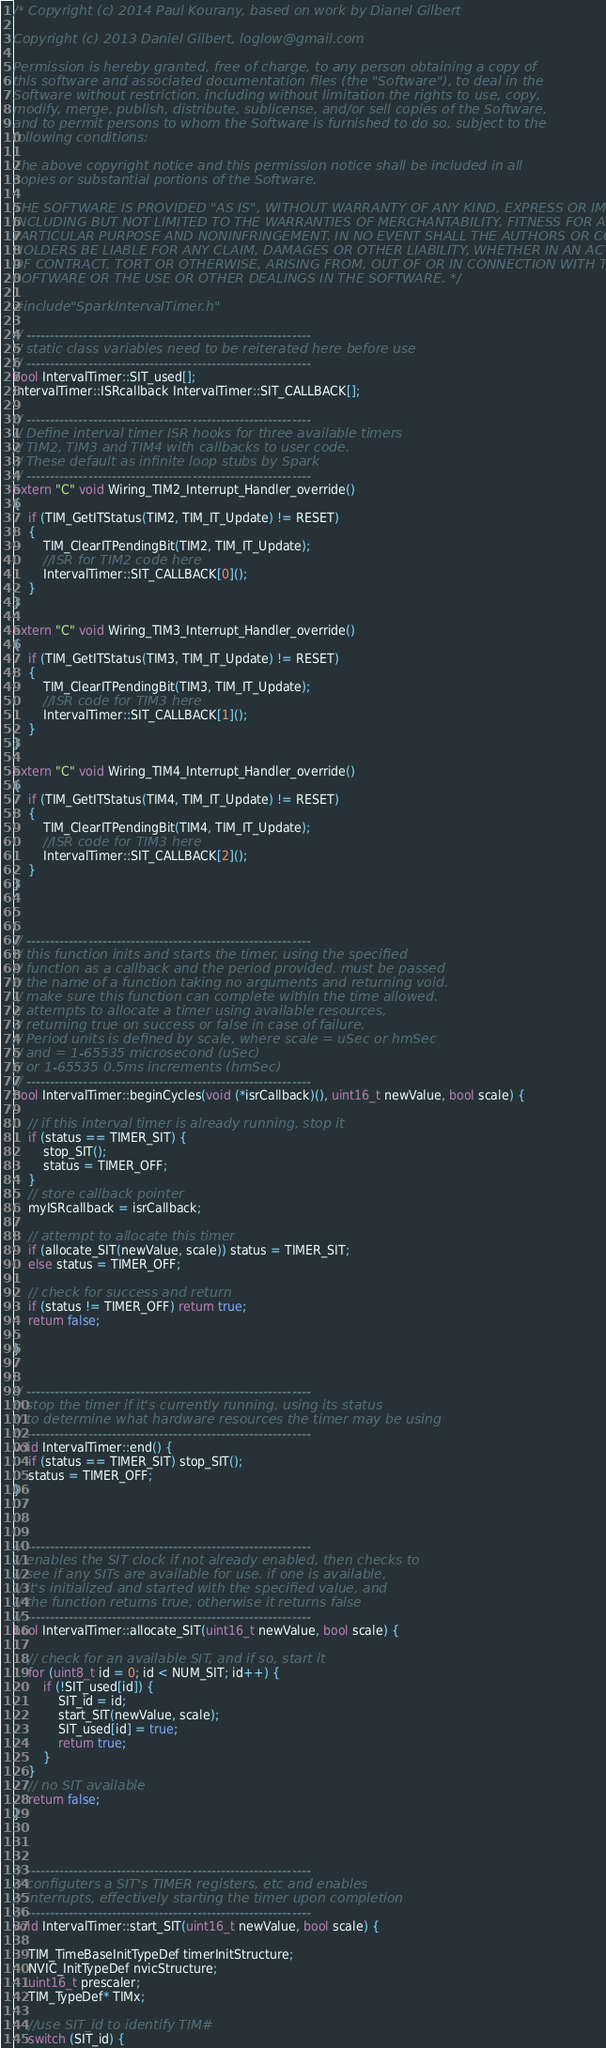<code> <loc_0><loc_0><loc_500><loc_500><_C++_>/* Copyright (c) 2014 Paul Kourany, based on work by Dianel Gilbert

Copyright (c) 2013 Daniel Gilbert, loglow@gmail.com

Permission is hereby granted, free of charge, to any person obtaining a copy of
this software and associated documentation files (the "Software"), to deal in the
Software without restriction, including without limitation the rights to use, copy,
modify, merge, publish, distribute, sublicense, and/or sell copies of the Software,
and to permit persons to whom the Software is furnished to do so, subject to the
following conditions:

The above copyright notice and this permission notice shall be included in all
copies or substantial portions of the Software.

THE SOFTWARE IS PROVIDED "AS IS", WITHOUT WARRANTY OF ANY KIND, EXPRESS OR IMPLIED,
INCLUDING BUT NOT LIMITED TO THE WARRANTIES OF MERCHANTABILITY, FITNESS FOR A
PARTICULAR PURPOSE AND NONINFRINGEMENT. IN NO EVENT SHALL THE AUTHORS OR COPYRIGHT
HOLDERS BE LIABLE FOR ANY CLAIM, DAMAGES OR OTHER LIABILITY, WHETHER IN AN ACTION
OF CONTRACT, TORT OR OTHERWISE, ARISING FROM, OUT OF OR IN CONNECTION WITH THE
SOFTWARE OR THE USE OR OTHER DEALINGS IN THE SOFTWARE. */

#include "SparkIntervalTimer.h"

// ------------------------------------------------------------
// static class variables need to be reiterated here before use
// ------------------------------------------------------------
bool IntervalTimer::SIT_used[];
IntervalTimer::ISRcallback IntervalTimer::SIT_CALLBACK[];

// ------------------------------------------------------------
// Define interval timer ISR hooks for three available timers
// TIM2, TIM3 and TIM4 with callbacks to user code.
// These default as infinite loop stubs by Spark
// ------------------------------------------------------------
extern "C" void Wiring_TIM2_Interrupt_Handler_override()
{
	if (TIM_GetITStatus(TIM2, TIM_IT_Update) != RESET)
	{
		TIM_ClearITPendingBit(TIM2, TIM_IT_Update);
		//ISR for TIM2 code here
		IntervalTimer::SIT_CALLBACK[0]();
	}
}

extern "C" void Wiring_TIM3_Interrupt_Handler_override()
{
	if (TIM_GetITStatus(TIM3, TIM_IT_Update) != RESET)
	{
		TIM_ClearITPendingBit(TIM3, TIM_IT_Update);
		//ISR code for TIM3 here
		IntervalTimer::SIT_CALLBACK[1]();
	}
}

extern "C" void Wiring_TIM4_Interrupt_Handler_override()
{
	if (TIM_GetITStatus(TIM4, TIM_IT_Update) != RESET)
	{
		TIM_ClearITPendingBit(TIM4, TIM_IT_Update);
		//ISR code for TIM3 here
		IntervalTimer::SIT_CALLBACK[2]();
	}
}



// ------------------------------------------------------------
// this function inits and starts the timer, using the specified
// function as a callback and the period provided. must be passed
// the name of a function taking no arguments and returning void.
// make sure this function can complete within the time allowed.
// attempts to allocate a timer using available resources,
// returning true on success or false in case of failure.
// Period units is defined by scale, where scale = uSec or hmSec
// and = 1-65535 microsecond (uSec)
// or 1-65535 0.5ms increments (hmSec)
// ------------------------------------------------------------
bool IntervalTimer::beginCycles(void (*isrCallback)(), uint16_t newValue, bool scale) {

	// if this interval timer is already running, stop it
	if (status == TIMER_SIT) {
		stop_SIT();
		status = TIMER_OFF;
	}
	// store callback pointer
	myISRcallback = isrCallback;

	// attempt to allocate this timer
	if (allocate_SIT(newValue, scale)) status = TIMER_SIT;
	else status = TIMER_OFF;

	// check for success and return
	if (status != TIMER_OFF) return true;
	return false;

}


// ------------------------------------------------------------
// stop the timer if it's currently running, using its status
// to determine what hardware resources the timer may be using
// ------------------------------------------------------------
void IntervalTimer::end() {
	if (status == TIMER_SIT) stop_SIT();
	status = TIMER_OFF;
}



// ------------------------------------------------------------
// enables the SIT clock if not already enabled, then checks to
// see if any SITs are available for use. if one is available,
// it's initialized and started with the specified value, and
// the function returns true, otherwise it returns false
// ------------------------------------------------------------
bool IntervalTimer::allocate_SIT(uint16_t newValue, bool scale) {

	// check for an available SIT, and if so, start it
	for (uint8_t id = 0; id < NUM_SIT; id++) {
		if (!SIT_used[id]) {
			SIT_id = id;
			start_SIT(newValue, scale);
			SIT_used[id] = true;
			return true;
		}
	}
	// no SIT available
	return false;
}



// ------------------------------------------------------------
// configuters a SIT's TIMER registers, etc and enables
// interrupts, effectively starting the timer upon completion
// ------------------------------------------------------------
void IntervalTimer::start_SIT(uint16_t newValue, bool scale) {

	TIM_TimeBaseInitTypeDef timerInitStructure;
    NVIC_InitTypeDef nvicStructure;
	uint16_t prescaler;
	TIM_TypeDef* TIMx;
	
	//use SIT_id to identify TIM#
	switch (SIT_id) {</code> 